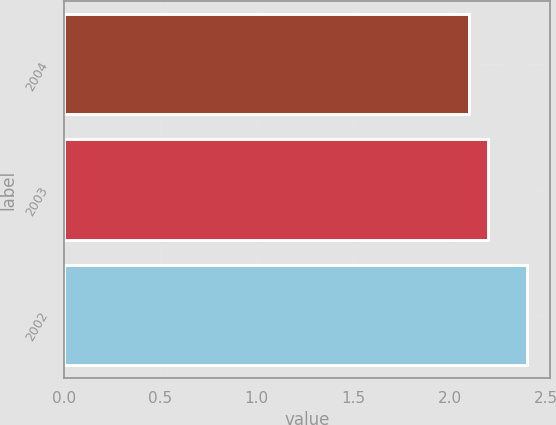Convert chart. <chart><loc_0><loc_0><loc_500><loc_500><bar_chart><fcel>2004<fcel>2003<fcel>2002<nl><fcel>2.1<fcel>2.2<fcel>2.4<nl></chart> 